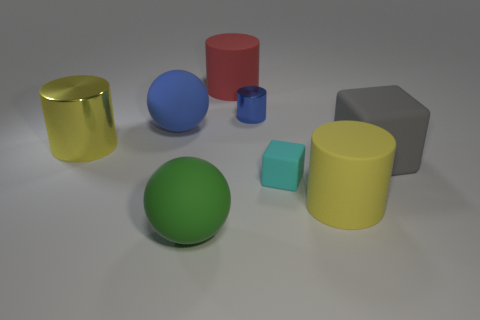Is the shape of the large yellow thing that is behind the gray object the same as  the large yellow matte thing?
Give a very brief answer. Yes. How many things are shiny things that are left of the big rubber cube or large purple matte blocks?
Your answer should be compact. 2. There is another rubber thing that is the same shape as the big blue rubber object; what is its color?
Make the answer very short. Green. Is there anything else that is the same color as the tiny rubber object?
Offer a terse response. No. There is a metallic cylinder that is to the left of the green matte thing; how big is it?
Offer a very short reply. Large. There is a tiny metallic thing; is it the same color as the ball behind the gray matte block?
Offer a terse response. Yes. What number of other things are the same material as the red cylinder?
Provide a succinct answer. 5. Is the number of small purple rubber cylinders greater than the number of large blue objects?
Offer a very short reply. No. There is a big rubber cylinder in front of the red rubber cylinder; is it the same color as the large metallic cylinder?
Provide a succinct answer. Yes. What color is the tiny metallic thing?
Your answer should be very brief. Blue. 